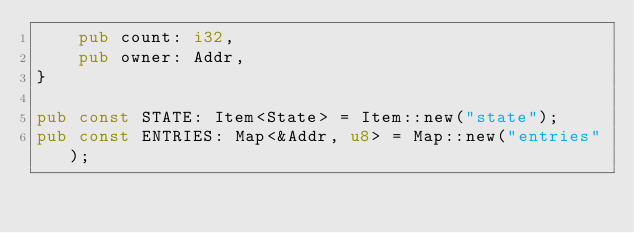<code> <loc_0><loc_0><loc_500><loc_500><_Rust_>    pub count: i32,
    pub owner: Addr,
}

pub const STATE: Item<State> = Item::new("state");
pub const ENTRIES: Map<&Addr, u8> = Map::new("entries");
</code> 